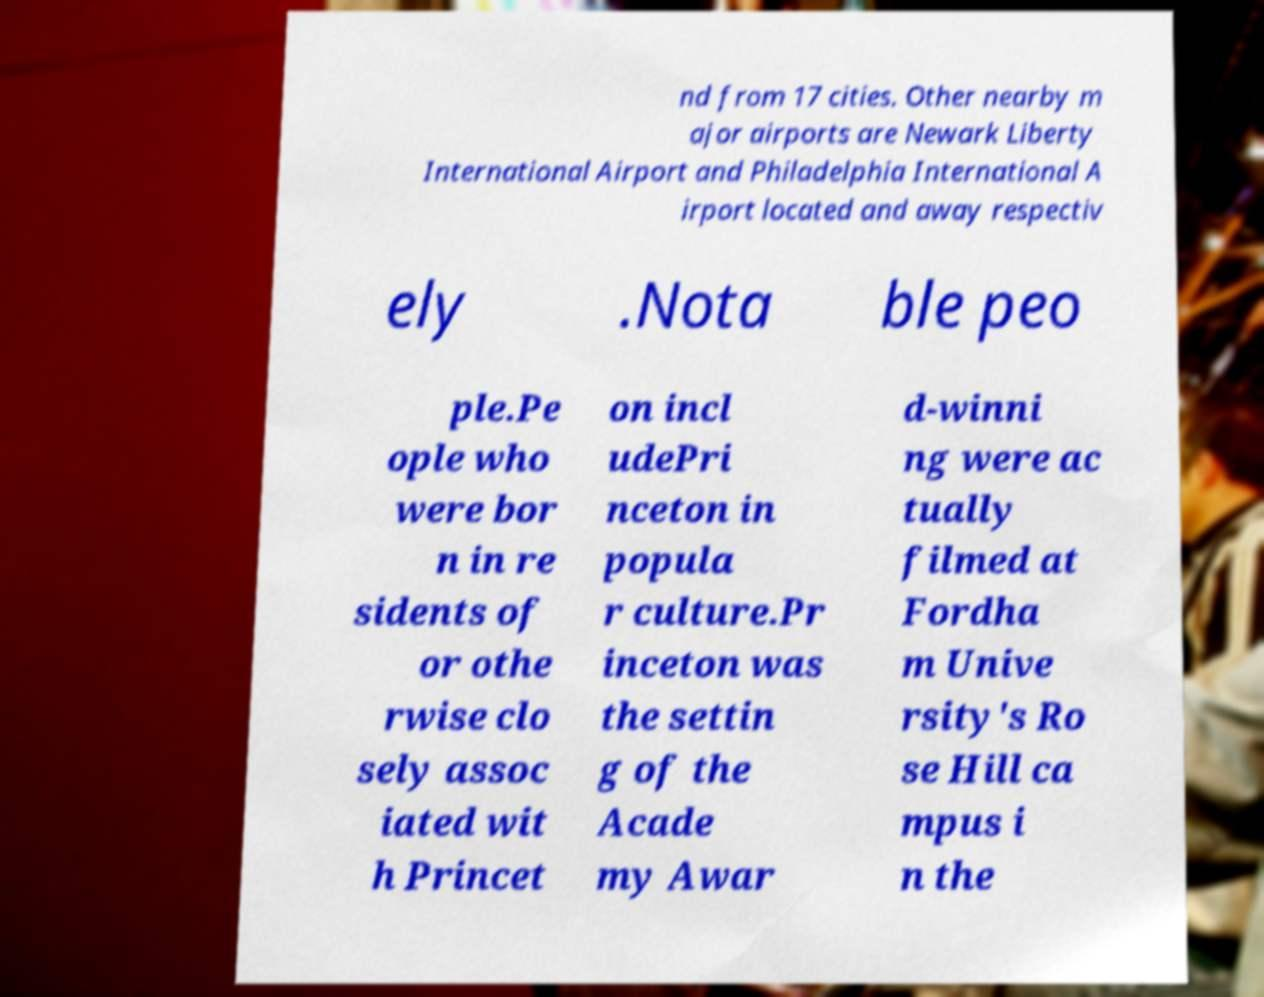Please read and relay the text visible in this image. What does it say? nd from 17 cities. Other nearby m ajor airports are Newark Liberty International Airport and Philadelphia International A irport located and away respectiv ely .Nota ble peo ple.Pe ople who were bor n in re sidents of or othe rwise clo sely assoc iated wit h Princet on incl udePri nceton in popula r culture.Pr inceton was the settin g of the Acade my Awar d-winni ng were ac tually filmed at Fordha m Unive rsity's Ro se Hill ca mpus i n the 